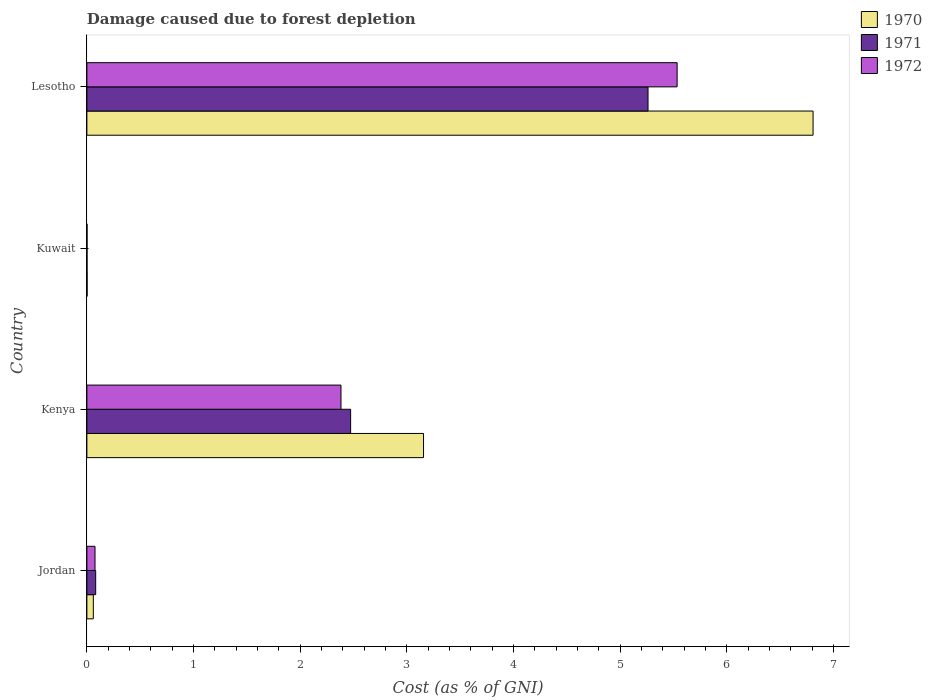How many different coloured bars are there?
Your answer should be compact. 3. How many groups of bars are there?
Your answer should be compact. 4. Are the number of bars on each tick of the Y-axis equal?
Provide a short and direct response. Yes. What is the label of the 3rd group of bars from the top?
Provide a short and direct response. Kenya. In how many cases, is the number of bars for a given country not equal to the number of legend labels?
Your answer should be compact. 0. What is the cost of damage caused due to forest depletion in 1972 in Kuwait?
Make the answer very short. 0. Across all countries, what is the maximum cost of damage caused due to forest depletion in 1971?
Offer a very short reply. 5.26. Across all countries, what is the minimum cost of damage caused due to forest depletion in 1971?
Give a very brief answer. 0. In which country was the cost of damage caused due to forest depletion in 1971 maximum?
Provide a short and direct response. Lesotho. In which country was the cost of damage caused due to forest depletion in 1971 minimum?
Ensure brevity in your answer.  Kuwait. What is the total cost of damage caused due to forest depletion in 1970 in the graph?
Provide a short and direct response. 10.03. What is the difference between the cost of damage caused due to forest depletion in 1970 in Jordan and that in Lesotho?
Provide a short and direct response. -6.75. What is the difference between the cost of damage caused due to forest depletion in 1971 in Kuwait and the cost of damage caused due to forest depletion in 1972 in Kenya?
Keep it short and to the point. -2.38. What is the average cost of damage caused due to forest depletion in 1970 per country?
Your answer should be compact. 2.51. What is the difference between the cost of damage caused due to forest depletion in 1971 and cost of damage caused due to forest depletion in 1972 in Kenya?
Your response must be concise. 0.09. In how many countries, is the cost of damage caused due to forest depletion in 1971 greater than 5.8 %?
Give a very brief answer. 0. What is the ratio of the cost of damage caused due to forest depletion in 1971 in Jordan to that in Kenya?
Offer a terse response. 0.03. Is the cost of damage caused due to forest depletion in 1971 in Kenya less than that in Kuwait?
Make the answer very short. No. Is the difference between the cost of damage caused due to forest depletion in 1971 in Jordan and Kenya greater than the difference between the cost of damage caused due to forest depletion in 1972 in Jordan and Kenya?
Your answer should be compact. No. What is the difference between the highest and the second highest cost of damage caused due to forest depletion in 1971?
Provide a short and direct response. 2.79. What is the difference between the highest and the lowest cost of damage caused due to forest depletion in 1971?
Provide a short and direct response. 5.26. What does the 2nd bar from the top in Kuwait represents?
Make the answer very short. 1971. How many bars are there?
Provide a succinct answer. 12. Are all the bars in the graph horizontal?
Ensure brevity in your answer.  Yes. Are the values on the major ticks of X-axis written in scientific E-notation?
Keep it short and to the point. No. Does the graph contain grids?
Your answer should be very brief. No. How are the legend labels stacked?
Offer a terse response. Vertical. What is the title of the graph?
Your answer should be compact. Damage caused due to forest depletion. Does "1980" appear as one of the legend labels in the graph?
Your response must be concise. No. What is the label or title of the X-axis?
Provide a succinct answer. Cost (as % of GNI). What is the Cost (as % of GNI) of 1970 in Jordan?
Make the answer very short. 0.06. What is the Cost (as % of GNI) in 1971 in Jordan?
Provide a succinct answer. 0.08. What is the Cost (as % of GNI) in 1972 in Jordan?
Your answer should be very brief. 0.08. What is the Cost (as % of GNI) of 1970 in Kenya?
Provide a succinct answer. 3.16. What is the Cost (as % of GNI) in 1971 in Kenya?
Your answer should be compact. 2.47. What is the Cost (as % of GNI) in 1972 in Kenya?
Your answer should be very brief. 2.38. What is the Cost (as % of GNI) of 1970 in Kuwait?
Your answer should be compact. 0. What is the Cost (as % of GNI) in 1971 in Kuwait?
Ensure brevity in your answer.  0. What is the Cost (as % of GNI) of 1972 in Kuwait?
Ensure brevity in your answer.  0. What is the Cost (as % of GNI) in 1970 in Lesotho?
Offer a very short reply. 6.81. What is the Cost (as % of GNI) in 1971 in Lesotho?
Offer a terse response. 5.26. What is the Cost (as % of GNI) of 1972 in Lesotho?
Ensure brevity in your answer.  5.53. Across all countries, what is the maximum Cost (as % of GNI) in 1970?
Make the answer very short. 6.81. Across all countries, what is the maximum Cost (as % of GNI) in 1971?
Ensure brevity in your answer.  5.26. Across all countries, what is the maximum Cost (as % of GNI) in 1972?
Your answer should be very brief. 5.53. Across all countries, what is the minimum Cost (as % of GNI) of 1970?
Offer a very short reply. 0. Across all countries, what is the minimum Cost (as % of GNI) of 1971?
Your answer should be very brief. 0. Across all countries, what is the minimum Cost (as % of GNI) of 1972?
Give a very brief answer. 0. What is the total Cost (as % of GNI) in 1970 in the graph?
Provide a succinct answer. 10.03. What is the total Cost (as % of GNI) of 1971 in the graph?
Give a very brief answer. 7.82. What is the total Cost (as % of GNI) of 1972 in the graph?
Your answer should be compact. 7.99. What is the difference between the Cost (as % of GNI) of 1970 in Jordan and that in Kenya?
Give a very brief answer. -3.1. What is the difference between the Cost (as % of GNI) of 1971 in Jordan and that in Kenya?
Ensure brevity in your answer.  -2.39. What is the difference between the Cost (as % of GNI) in 1972 in Jordan and that in Kenya?
Your response must be concise. -2.31. What is the difference between the Cost (as % of GNI) in 1970 in Jordan and that in Kuwait?
Provide a short and direct response. 0.06. What is the difference between the Cost (as % of GNI) of 1971 in Jordan and that in Kuwait?
Keep it short and to the point. 0.08. What is the difference between the Cost (as % of GNI) of 1972 in Jordan and that in Kuwait?
Your response must be concise. 0.07. What is the difference between the Cost (as % of GNI) in 1970 in Jordan and that in Lesotho?
Give a very brief answer. -6.75. What is the difference between the Cost (as % of GNI) of 1971 in Jordan and that in Lesotho?
Provide a succinct answer. -5.18. What is the difference between the Cost (as % of GNI) in 1972 in Jordan and that in Lesotho?
Give a very brief answer. -5.46. What is the difference between the Cost (as % of GNI) in 1970 in Kenya and that in Kuwait?
Offer a terse response. 3.15. What is the difference between the Cost (as % of GNI) of 1971 in Kenya and that in Kuwait?
Keep it short and to the point. 2.47. What is the difference between the Cost (as % of GNI) of 1972 in Kenya and that in Kuwait?
Provide a short and direct response. 2.38. What is the difference between the Cost (as % of GNI) in 1970 in Kenya and that in Lesotho?
Provide a short and direct response. -3.65. What is the difference between the Cost (as % of GNI) of 1971 in Kenya and that in Lesotho?
Ensure brevity in your answer.  -2.79. What is the difference between the Cost (as % of GNI) in 1972 in Kenya and that in Lesotho?
Your answer should be very brief. -3.15. What is the difference between the Cost (as % of GNI) in 1970 in Kuwait and that in Lesotho?
Keep it short and to the point. -6.81. What is the difference between the Cost (as % of GNI) of 1971 in Kuwait and that in Lesotho?
Provide a short and direct response. -5.26. What is the difference between the Cost (as % of GNI) in 1972 in Kuwait and that in Lesotho?
Provide a succinct answer. -5.53. What is the difference between the Cost (as % of GNI) in 1970 in Jordan and the Cost (as % of GNI) in 1971 in Kenya?
Your answer should be very brief. -2.41. What is the difference between the Cost (as % of GNI) of 1970 in Jordan and the Cost (as % of GNI) of 1972 in Kenya?
Your response must be concise. -2.32. What is the difference between the Cost (as % of GNI) of 1971 in Jordan and the Cost (as % of GNI) of 1972 in Kenya?
Offer a very short reply. -2.3. What is the difference between the Cost (as % of GNI) of 1970 in Jordan and the Cost (as % of GNI) of 1971 in Kuwait?
Your response must be concise. 0.06. What is the difference between the Cost (as % of GNI) of 1970 in Jordan and the Cost (as % of GNI) of 1972 in Kuwait?
Give a very brief answer. 0.06. What is the difference between the Cost (as % of GNI) of 1971 in Jordan and the Cost (as % of GNI) of 1972 in Kuwait?
Provide a short and direct response. 0.08. What is the difference between the Cost (as % of GNI) in 1970 in Jordan and the Cost (as % of GNI) in 1971 in Lesotho?
Offer a very short reply. -5.2. What is the difference between the Cost (as % of GNI) of 1970 in Jordan and the Cost (as % of GNI) of 1972 in Lesotho?
Your answer should be very brief. -5.47. What is the difference between the Cost (as % of GNI) of 1971 in Jordan and the Cost (as % of GNI) of 1972 in Lesotho?
Provide a short and direct response. -5.45. What is the difference between the Cost (as % of GNI) of 1970 in Kenya and the Cost (as % of GNI) of 1971 in Kuwait?
Your answer should be very brief. 3.16. What is the difference between the Cost (as % of GNI) of 1970 in Kenya and the Cost (as % of GNI) of 1972 in Kuwait?
Provide a short and direct response. 3.16. What is the difference between the Cost (as % of GNI) in 1971 in Kenya and the Cost (as % of GNI) in 1972 in Kuwait?
Provide a succinct answer. 2.47. What is the difference between the Cost (as % of GNI) of 1970 in Kenya and the Cost (as % of GNI) of 1971 in Lesotho?
Provide a succinct answer. -2.1. What is the difference between the Cost (as % of GNI) of 1970 in Kenya and the Cost (as % of GNI) of 1972 in Lesotho?
Your answer should be compact. -2.38. What is the difference between the Cost (as % of GNI) in 1971 in Kenya and the Cost (as % of GNI) in 1972 in Lesotho?
Your answer should be very brief. -3.06. What is the difference between the Cost (as % of GNI) of 1970 in Kuwait and the Cost (as % of GNI) of 1971 in Lesotho?
Provide a short and direct response. -5.26. What is the difference between the Cost (as % of GNI) in 1970 in Kuwait and the Cost (as % of GNI) in 1972 in Lesotho?
Provide a succinct answer. -5.53. What is the difference between the Cost (as % of GNI) of 1971 in Kuwait and the Cost (as % of GNI) of 1972 in Lesotho?
Keep it short and to the point. -5.53. What is the average Cost (as % of GNI) of 1970 per country?
Your response must be concise. 2.51. What is the average Cost (as % of GNI) of 1971 per country?
Keep it short and to the point. 1.95. What is the average Cost (as % of GNI) in 1972 per country?
Offer a very short reply. 2. What is the difference between the Cost (as % of GNI) in 1970 and Cost (as % of GNI) in 1971 in Jordan?
Offer a terse response. -0.02. What is the difference between the Cost (as % of GNI) of 1970 and Cost (as % of GNI) of 1972 in Jordan?
Provide a succinct answer. -0.02. What is the difference between the Cost (as % of GNI) in 1971 and Cost (as % of GNI) in 1972 in Jordan?
Offer a very short reply. 0.01. What is the difference between the Cost (as % of GNI) in 1970 and Cost (as % of GNI) in 1971 in Kenya?
Your answer should be very brief. 0.68. What is the difference between the Cost (as % of GNI) of 1970 and Cost (as % of GNI) of 1972 in Kenya?
Offer a very short reply. 0.77. What is the difference between the Cost (as % of GNI) in 1971 and Cost (as % of GNI) in 1972 in Kenya?
Make the answer very short. 0.09. What is the difference between the Cost (as % of GNI) of 1970 and Cost (as % of GNI) of 1971 in Kuwait?
Provide a succinct answer. 0. What is the difference between the Cost (as % of GNI) in 1970 and Cost (as % of GNI) in 1972 in Kuwait?
Offer a very short reply. 0. What is the difference between the Cost (as % of GNI) of 1971 and Cost (as % of GNI) of 1972 in Kuwait?
Your response must be concise. -0. What is the difference between the Cost (as % of GNI) of 1970 and Cost (as % of GNI) of 1971 in Lesotho?
Ensure brevity in your answer.  1.55. What is the difference between the Cost (as % of GNI) of 1970 and Cost (as % of GNI) of 1972 in Lesotho?
Offer a terse response. 1.27. What is the difference between the Cost (as % of GNI) in 1971 and Cost (as % of GNI) in 1972 in Lesotho?
Keep it short and to the point. -0.27. What is the ratio of the Cost (as % of GNI) in 1970 in Jordan to that in Kenya?
Your answer should be very brief. 0.02. What is the ratio of the Cost (as % of GNI) of 1972 in Jordan to that in Kenya?
Provide a succinct answer. 0.03. What is the ratio of the Cost (as % of GNI) of 1970 in Jordan to that in Kuwait?
Offer a terse response. 29.43. What is the ratio of the Cost (as % of GNI) of 1971 in Jordan to that in Kuwait?
Your response must be concise. 68.45. What is the ratio of the Cost (as % of GNI) of 1972 in Jordan to that in Kuwait?
Offer a very short reply. 57.8. What is the ratio of the Cost (as % of GNI) of 1970 in Jordan to that in Lesotho?
Offer a very short reply. 0.01. What is the ratio of the Cost (as % of GNI) in 1971 in Jordan to that in Lesotho?
Offer a terse response. 0.02. What is the ratio of the Cost (as % of GNI) of 1972 in Jordan to that in Lesotho?
Offer a terse response. 0.01. What is the ratio of the Cost (as % of GNI) of 1970 in Kenya to that in Kuwait?
Your response must be concise. 1538.88. What is the ratio of the Cost (as % of GNI) of 1971 in Kenya to that in Kuwait?
Keep it short and to the point. 2052.57. What is the ratio of the Cost (as % of GNI) of 1972 in Kenya to that in Kuwait?
Provide a succinct answer. 1809.3. What is the ratio of the Cost (as % of GNI) in 1970 in Kenya to that in Lesotho?
Ensure brevity in your answer.  0.46. What is the ratio of the Cost (as % of GNI) of 1971 in Kenya to that in Lesotho?
Offer a very short reply. 0.47. What is the ratio of the Cost (as % of GNI) of 1972 in Kenya to that in Lesotho?
Make the answer very short. 0.43. What is the ratio of the Cost (as % of GNI) in 1970 in Kuwait to that in Lesotho?
Offer a terse response. 0. What is the ratio of the Cost (as % of GNI) of 1971 in Kuwait to that in Lesotho?
Offer a very short reply. 0. What is the ratio of the Cost (as % of GNI) in 1972 in Kuwait to that in Lesotho?
Give a very brief answer. 0. What is the difference between the highest and the second highest Cost (as % of GNI) of 1970?
Provide a short and direct response. 3.65. What is the difference between the highest and the second highest Cost (as % of GNI) in 1971?
Offer a terse response. 2.79. What is the difference between the highest and the second highest Cost (as % of GNI) in 1972?
Offer a very short reply. 3.15. What is the difference between the highest and the lowest Cost (as % of GNI) in 1970?
Offer a very short reply. 6.81. What is the difference between the highest and the lowest Cost (as % of GNI) in 1971?
Provide a short and direct response. 5.26. What is the difference between the highest and the lowest Cost (as % of GNI) in 1972?
Provide a succinct answer. 5.53. 